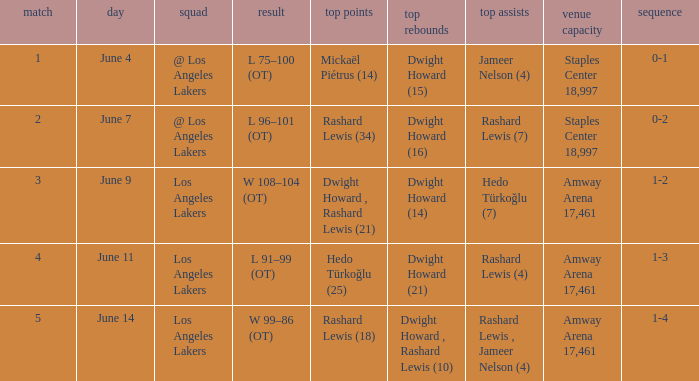What is Series, when Date is "June 7"? 0-2. Could you help me parse every detail presented in this table? {'header': ['match', 'day', 'squad', 'result', 'top points', 'top rebounds', 'top assists', 'venue capacity', 'sequence'], 'rows': [['1', 'June 4', '@ Los Angeles Lakers', 'L 75–100 (OT)', 'Mickaël Piétrus (14)', 'Dwight Howard (15)', 'Jameer Nelson (4)', 'Staples Center 18,997', '0-1'], ['2', 'June 7', '@ Los Angeles Lakers', 'L 96–101 (OT)', 'Rashard Lewis (34)', 'Dwight Howard (16)', 'Rashard Lewis (7)', 'Staples Center 18,997', '0-2'], ['3', 'June 9', 'Los Angeles Lakers', 'W 108–104 (OT)', 'Dwight Howard , Rashard Lewis (21)', 'Dwight Howard (14)', 'Hedo Türkoğlu (7)', 'Amway Arena 17,461', '1-2'], ['4', 'June 11', 'Los Angeles Lakers', 'L 91–99 (OT)', 'Hedo Türkoğlu (25)', 'Dwight Howard (21)', 'Rashard Lewis (4)', 'Amway Arena 17,461', '1-3'], ['5', 'June 14', 'Los Angeles Lakers', 'W 99–86 (OT)', 'Rashard Lewis (18)', 'Dwight Howard , Rashard Lewis (10)', 'Rashard Lewis , Jameer Nelson (4)', 'Amway Arena 17,461', '1-4']]} 